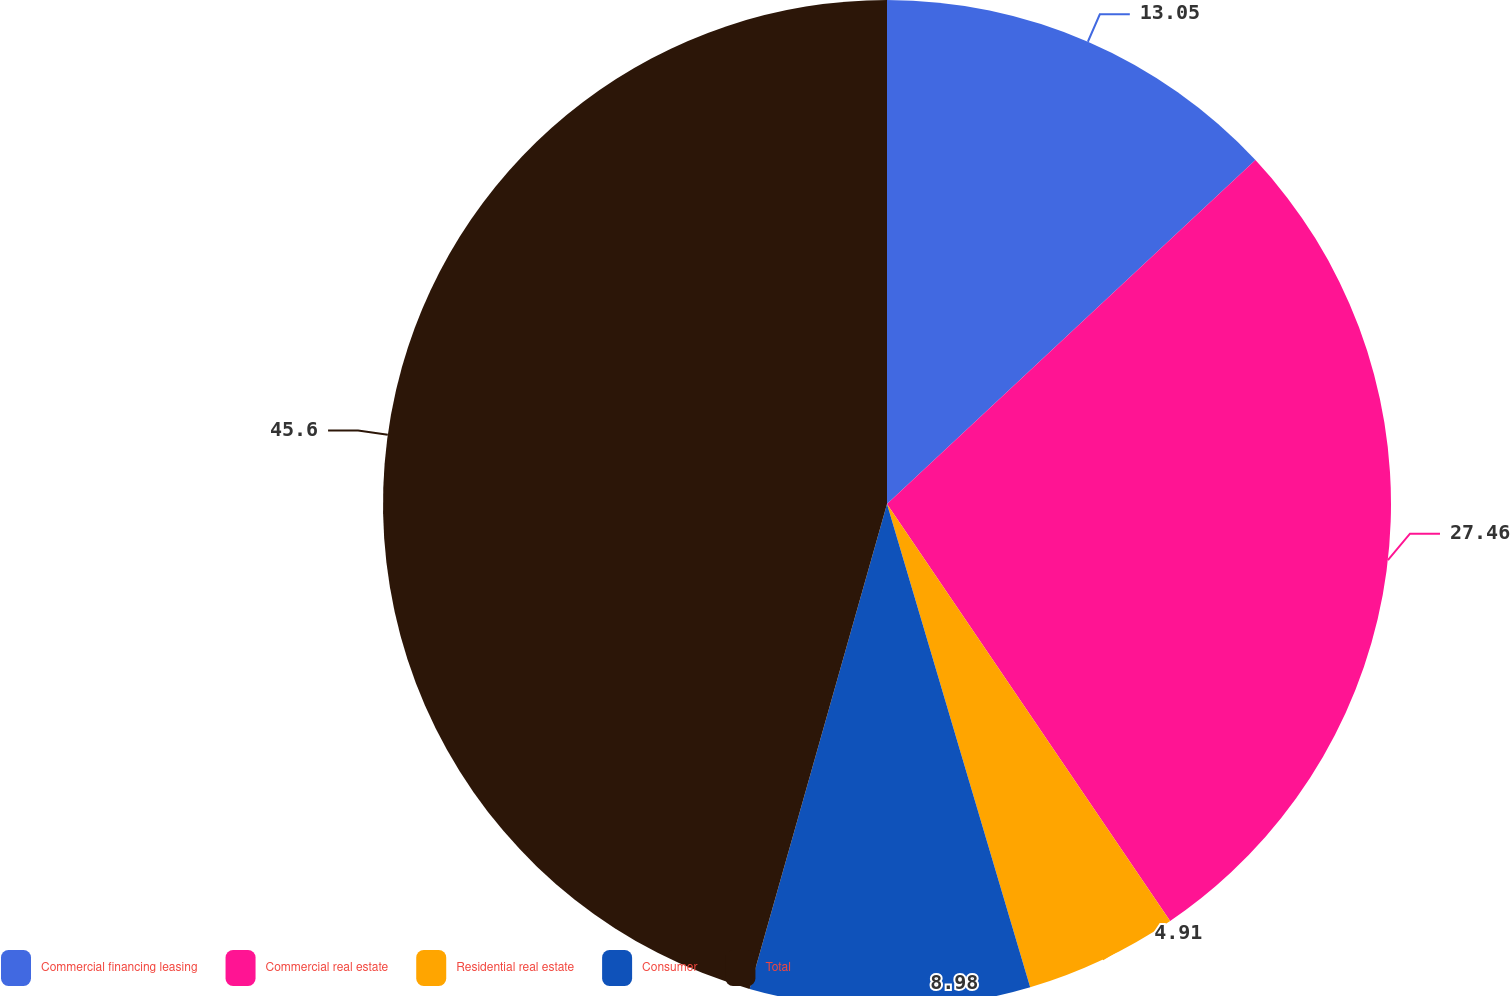<chart> <loc_0><loc_0><loc_500><loc_500><pie_chart><fcel>Commercial financing leasing<fcel>Commercial real estate<fcel>Residential real estate<fcel>Consumer<fcel>Total<nl><fcel>13.05%<fcel>27.46%<fcel>4.91%<fcel>8.98%<fcel>45.61%<nl></chart> 